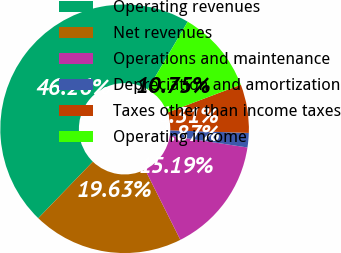<chart> <loc_0><loc_0><loc_500><loc_500><pie_chart><fcel>Operating revenues<fcel>Net revenues<fcel>Operations and maintenance<fcel>Depreciation and amortization<fcel>Taxes other than income taxes<fcel>Operating income<nl><fcel>46.27%<fcel>19.63%<fcel>15.19%<fcel>1.87%<fcel>6.31%<fcel>10.75%<nl></chart> 